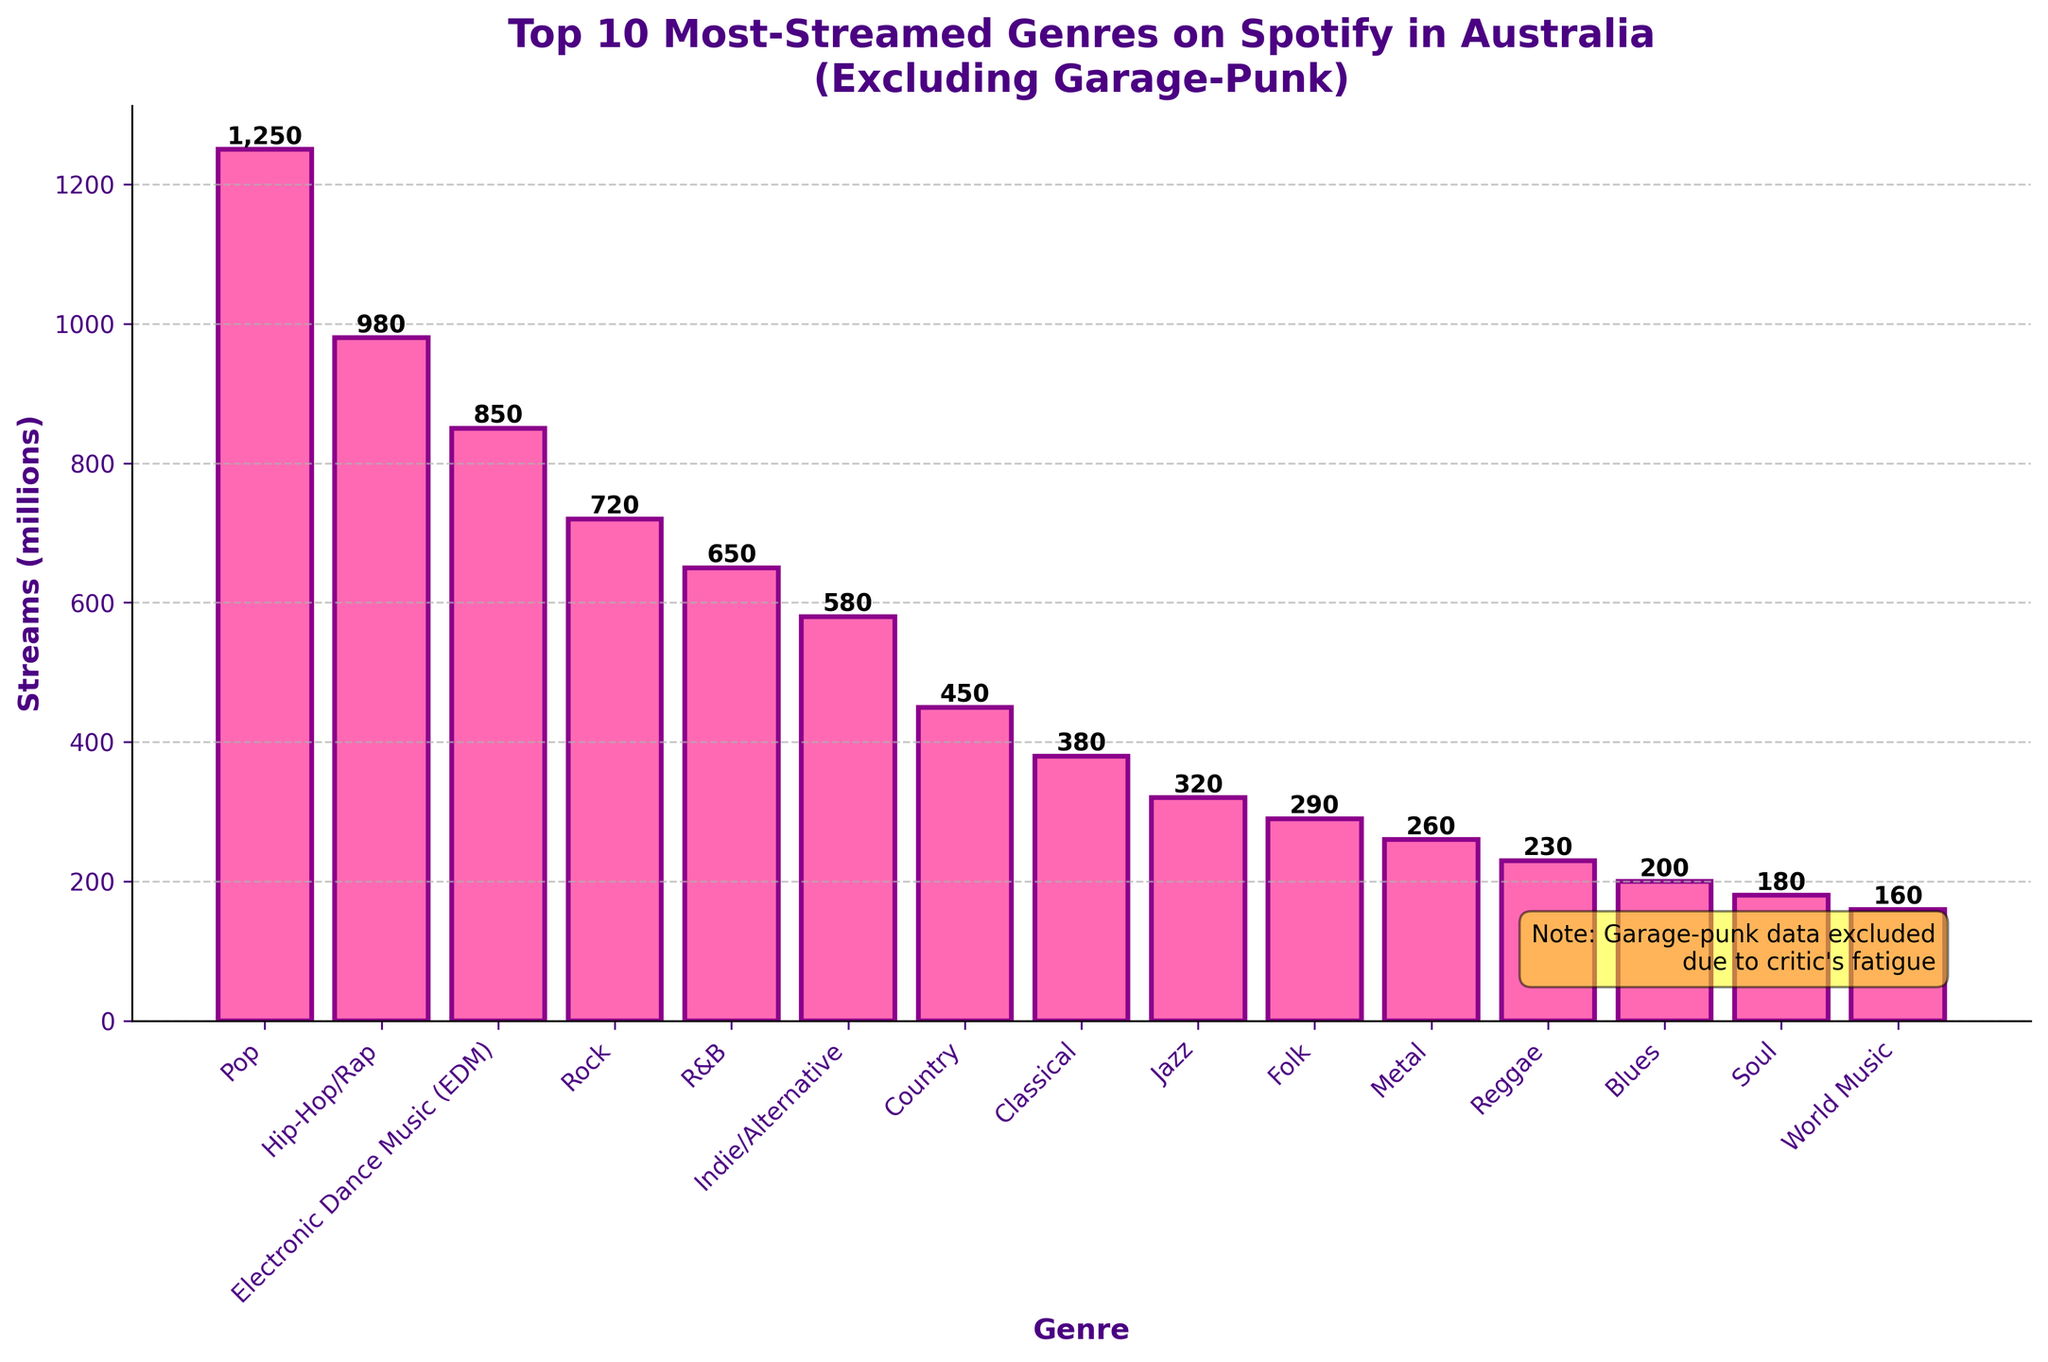What's the most-streamed genre in Australia according to the chart? The bar chart shows the heights of different genres representing the number of streams. The genre with the tallest bar represents the most-streamed genre, which is Pop with 1250 million streams.
Answer: Pop Which genre has fewer streams: Jazz or Folk? Compare the heights of the bars representing Jazz and Folk. Jazz has 320 million streams and Folk has 290 million streams, making Folk the genre with fewer streams.
Answer: Folk What is the total number of streams for the top 3 genres? The top three genres by height are Pop, Hip-Hop/Rap, and Electronic Dance Music (EDM). Adding their streams gives 1250 + 980 + 850 = 3080 million streams in total.
Answer: 3080 million How much more popular is Rock compared to Metal in terms of streams? Find the heights of the Rock and Metal bars, which are 720 million for Rock and 260 million for Metal. Subtract the number of streams of Metal from Rock, which results in 720 - 260 = 460 million more streams for Rock.
Answer: 460 million What fraction of the total streams for the top 10 genres is from Indie/Alternative? First calculate the total streams by adding the streams of the top 10 genres: 1250 + 980 + 850 + 720 + 650 + 580 + 450 + 380 + 320 + 290 = 6470 million. Then, find the fraction that Indie/Alternative contributes: 580 / 6470 ≈ 0.0896, which is approximately 8.96%.
Answer: 8.96% Which genre has more streams, R&B or Country? Compare the height of the bars representing R&B and Country. R&B has 650 million streams and Country has 450 million streams, so R&B has more streams.
Answer: R&B What is the average number of streams for Classical, Jazz, and Blues? Find the number of streams for Classical, Jazz, and Blues: 380, 320, and 200 million respectively. Add these numbers and divide by 3 to find the average: (380 + 320 + 200) / 3 = 300 million.
Answer: 300 million How many more streams does Pop have than Indie/Alternative? Compare the bars for Pop and Indie/Alternative, which have 1250 million and 580 million streams respectively. The difference is 1250 - 580 = 670 million streams.
Answer: 670 million What are the genres with fewer than 500 million streams? Identify the bars representing genres with streams under 500 million. They are Indie/Alternative, Country, Classical, Jazz, Folk, Metal, and Reggae, Blues, Soul, and World Music which have 580, 450, 380, 320, 290, 260, 230, 200, 180 and 160 million streams. Excluding Indie/Alternative as it's just above 500.
Answer: Country, Classical, Jazz, Folk, Metal, Reggae, Blues, Soul, World Music Which genre has the smallest number of streams? The bar with the shortest height represents World Music with 160 million streams.
Answer: World Music 